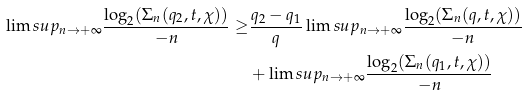Convert formula to latex. <formula><loc_0><loc_0><loc_500><loc_500>\lim s u p _ { n \to + \infty } \frac { \log _ { 2 } ( \Sigma _ { n } ( q _ { 2 } , t , \chi ) ) } { - n } \geq & \frac { q _ { 2 } - q _ { 1 } } { q } \lim s u p _ { n \to + \infty } \frac { \log _ { 2 } ( \Sigma _ { n } ( q , t , \chi ) ) } { - n } \\ & + \lim s u p _ { n \to + \infty } \frac { \log _ { 2 } ( \Sigma _ { n } ( q _ { 1 } , t , \chi ) ) } { - n }</formula> 